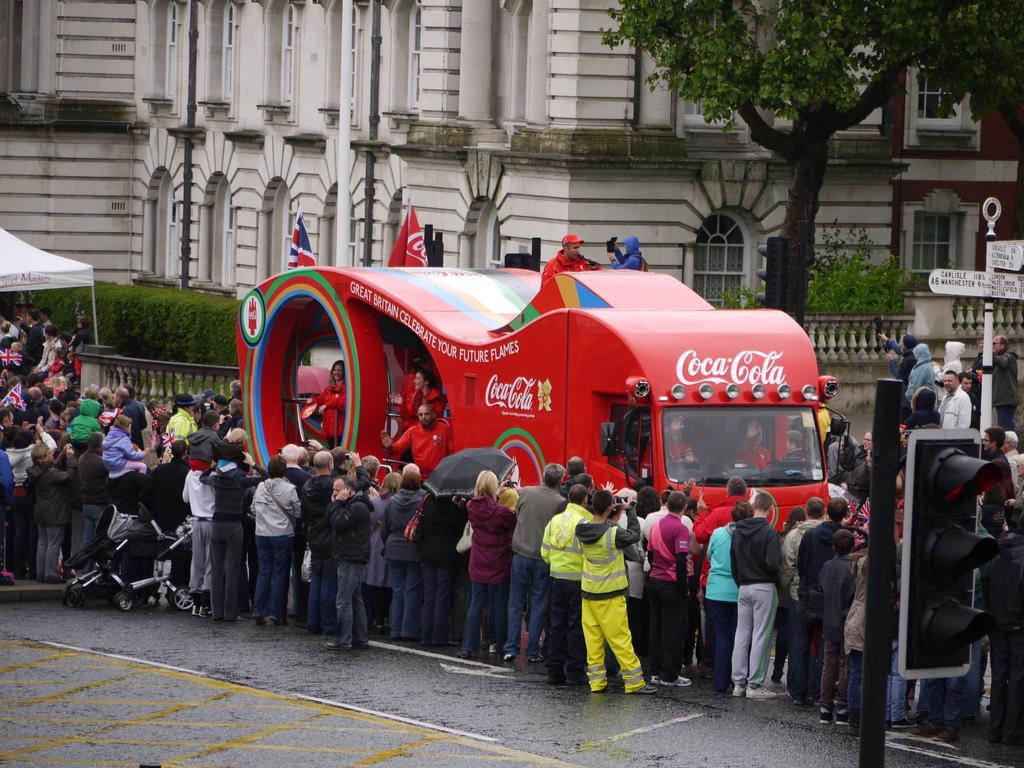Could you give a brief overview of what you see in this image? In this image there is a red vehicle on the road. There are many people standing around the vehicle. In the background there is building, trees, plants, boundary. In the foreground there is a path. In the right there is a traffic signal. 